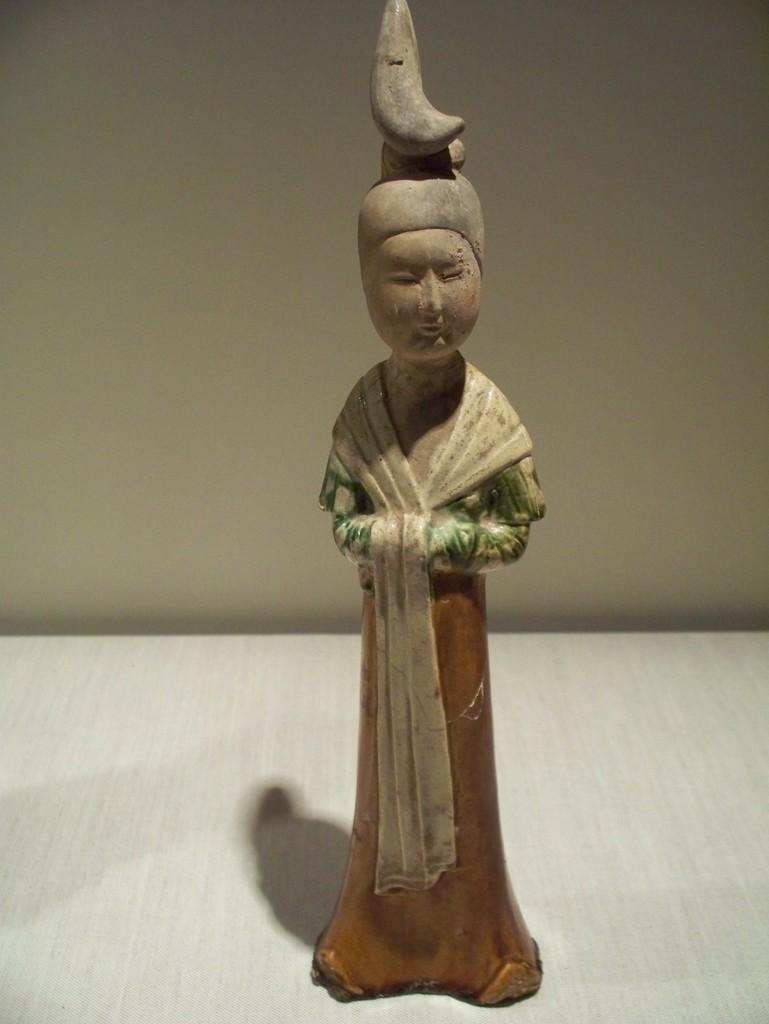What is on the table in the image? There is a person idol on the table. What is the person idol wearing? The person idol is wearing a dress. What type of drum is being played by the person idol in the image? There is no drum present in the image; the person idol is simply a statue wearing a dress. 